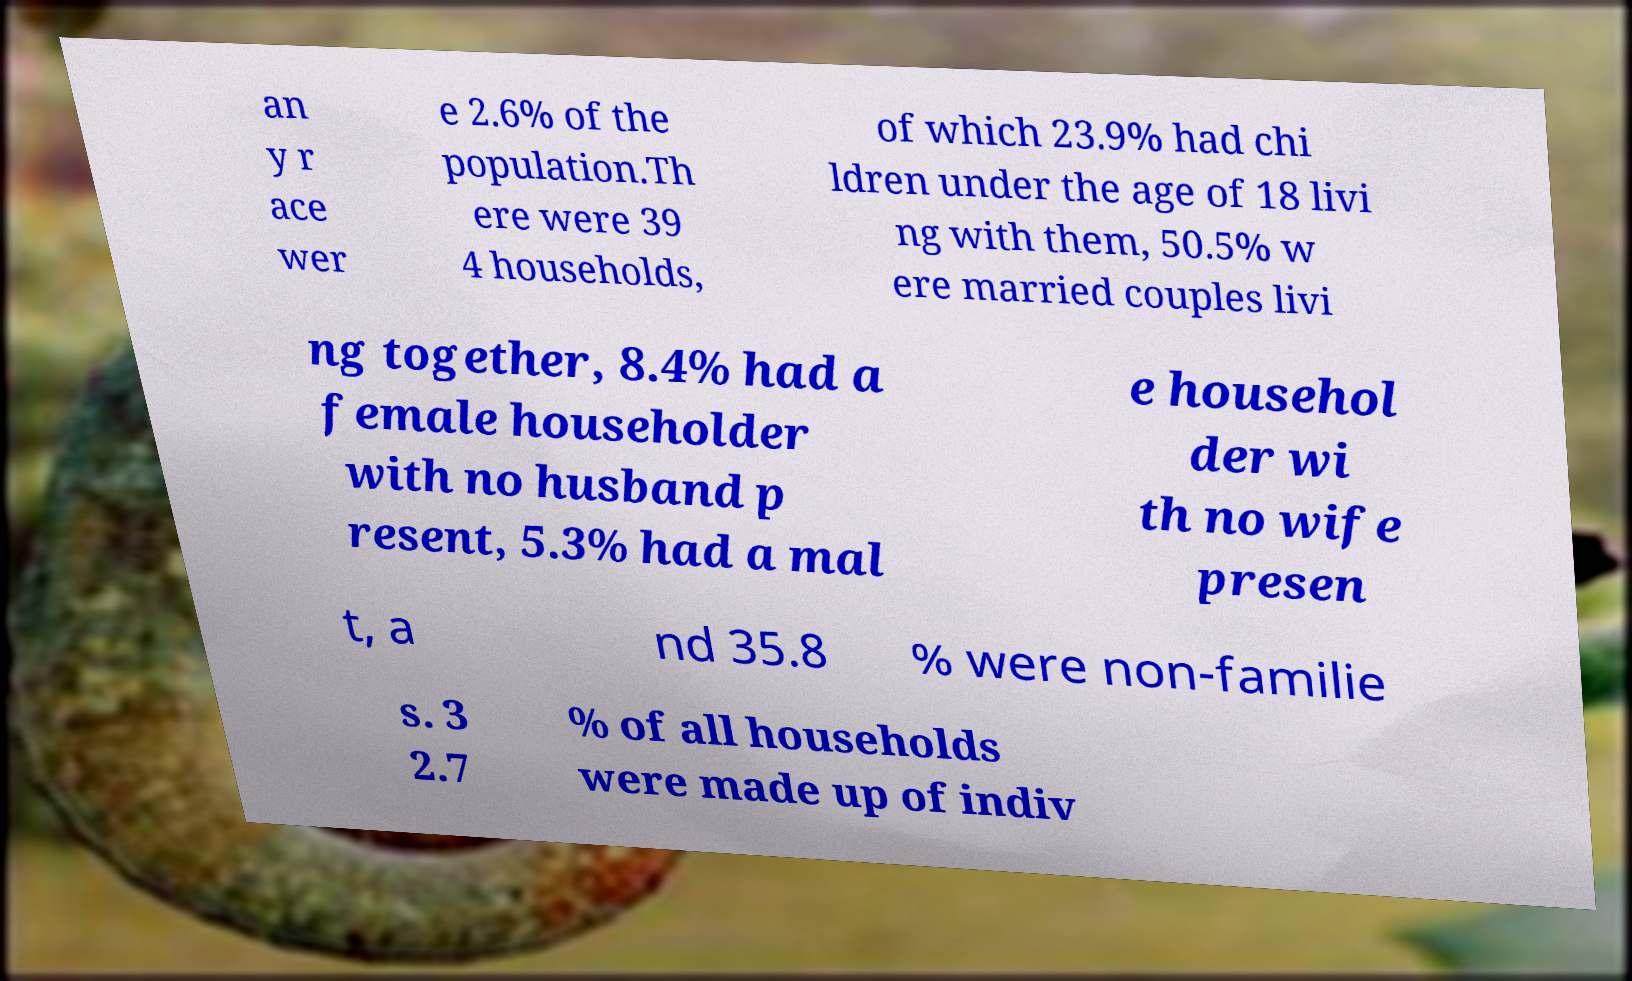Can you read and provide the text displayed in the image?This photo seems to have some interesting text. Can you extract and type it out for me? an y r ace wer e 2.6% of the population.Th ere were 39 4 households, of which 23.9% had chi ldren under the age of 18 livi ng with them, 50.5% w ere married couples livi ng together, 8.4% had a female householder with no husband p resent, 5.3% had a mal e househol der wi th no wife presen t, a nd 35.8 % were non-familie s. 3 2.7 % of all households were made up of indiv 